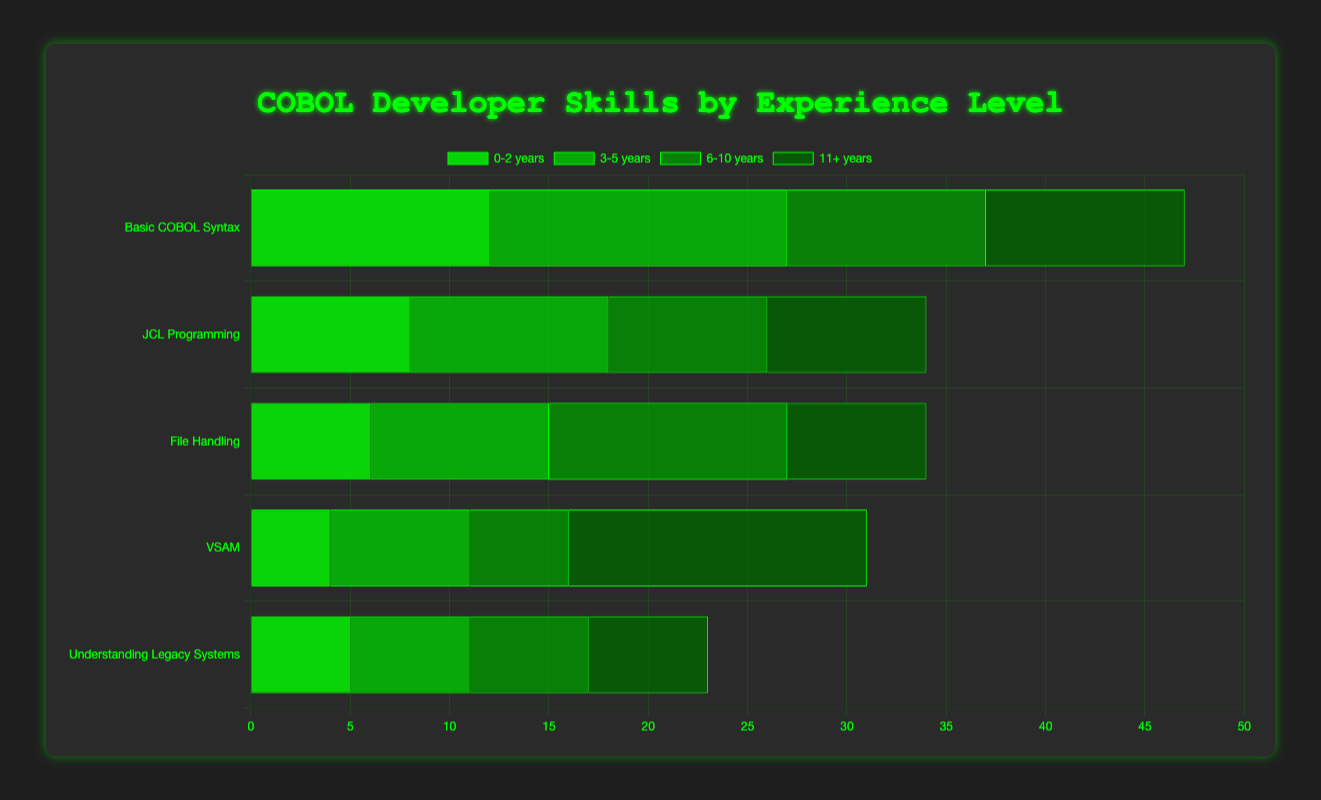What skill area has the highest number of employees with 0-2 years of experience? The 0-2 years group has employees distributed across different skills. The highest count is for Basic COBOL Syntax with 12 employees.
Answer: Basic COBOL Syntax Which experience group has the most employees skilled in Performance Tuning? Visual inspection of the Performance Tuning bars shows employees only in the 3-5 years group, totaling 7.
Answer: 3-5 years Comparing System Design and Enterprise Architecture, which skill has more experienced employees (6-10 years vs 11+ years)? For System Design (6-10 years), there are 10 employees. For Enterprise Architecture (11+ years), there are also 10. Hence, both have the same number.
Answer: Equal What is the total number of employees proficient in DB2 Integration and COBOL-DB2 Optimization across all experience levels? Summing the employees: DB2 Integration has 10 (3-5 years) and COBOL-DB2 Optimization has 12 (6-10 years), totaling 10 + 12 = 22.
Answer: 22 Which experience category has more employees skilled in Legacy System Modernization or Understanding Legacy Systems? The 11+ years group has 15 employees skilled in Legacy System Modernization, while the 0-2 years group has 5 in Understanding Legacy Systems. Therefore, the 11+ years group has more.
Answer: 11+ years What is the average number of employees proficient in Troubleshooting & Debugging and Cross-Platform Integration combined? There are 6 employees for Troubleshooting & Debugging and 6 for Cross-Platform Integration. The average is (6 + 6) / 2 = 6.
Answer: 6 Which skill has the smallest number of experienced employees within 0-2 years group? From the 0-2 years group, VSAM has the smallest number of employees, totaling 4.
Answer: VSAM Which skill area shows the most significant difference in employee count between the 6-10 years and the 11+ years experience groups? Comparing each skill count across 6-10 years and 11+ years, Legacy System Modernization (15 for 11+ years) and Mentoring & Training (5 for 6-10 years) yields the largest difference of 15 - 5 = 10.
Answer: Mentoring & Training vs. Legacy System Modernization How many employees are skilled in both Unit Testing and Code Review? Only the 3-5 years group has employees skilled in Unit Testing (9) and the 6-10 years group skilled in Code Review (6). These skills are mutually exclusive per group, meaning there’s no overlap.
Answer: 0 